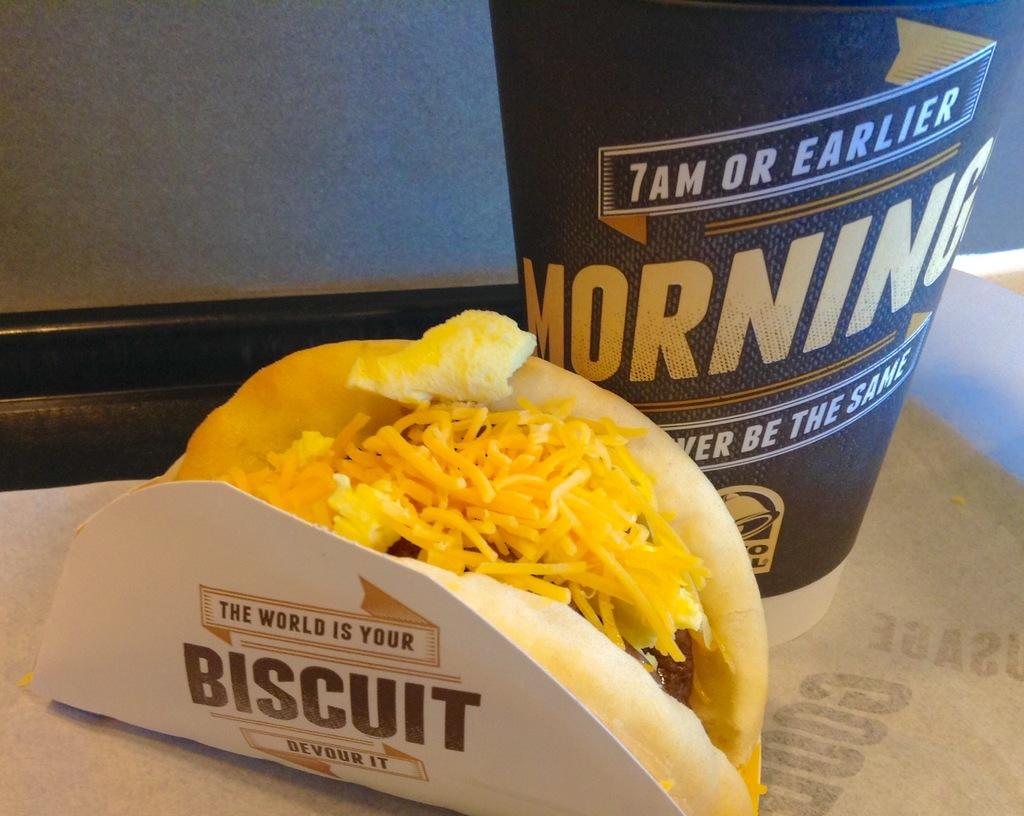What is present in the image that can be used for drinking? There is a glass in the image that can be used for drinking. What is present in the image that can be consumed? There is food in the image that can be consumed. What is present in the image that can be used for writing or reading? There is paper in the image that can be used for writing or reading. Where are the glass, food, and paper located in the image? The glass, food, and paper are placed on a platform in the image. What can be seen in the background of the image? There is a wall in the background of the image. What type of sock is being used as a cause for the food in the image? There is no sock present in the image, and no cause for the food is mentioned or depicted. 